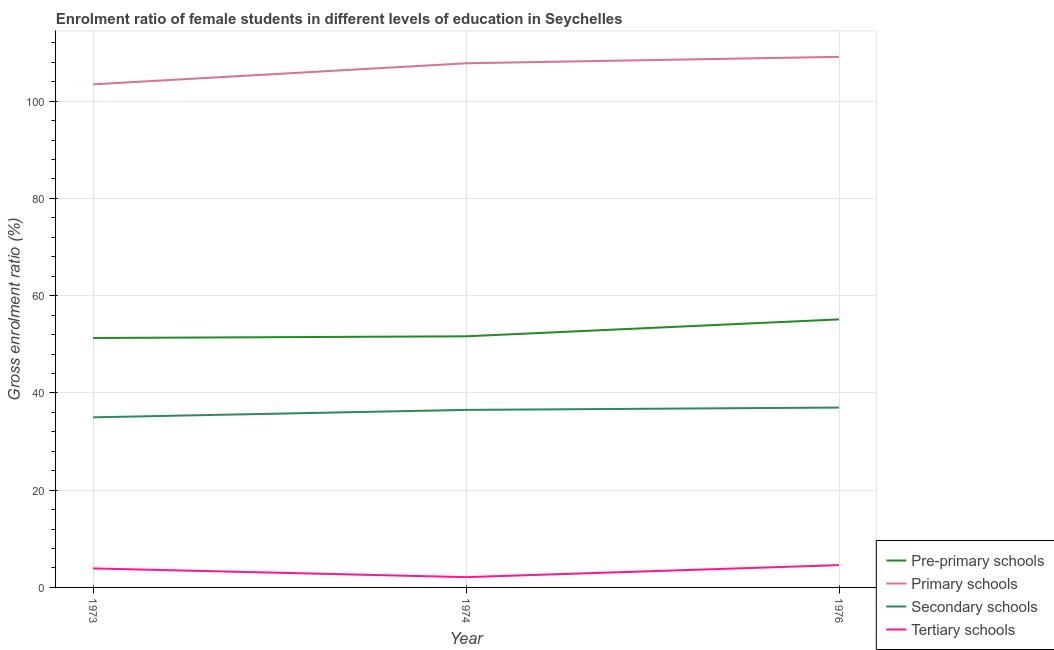How many different coloured lines are there?
Provide a succinct answer. 4. Is the number of lines equal to the number of legend labels?
Make the answer very short. Yes. What is the gross enrolment ratio(male) in secondary schools in 1973?
Your answer should be compact. 34.98. Across all years, what is the maximum gross enrolment ratio(male) in pre-primary schools?
Offer a terse response. 55.12. Across all years, what is the minimum gross enrolment ratio(male) in pre-primary schools?
Your answer should be very brief. 51.3. In which year was the gross enrolment ratio(male) in secondary schools maximum?
Offer a very short reply. 1976. What is the total gross enrolment ratio(male) in tertiary schools in the graph?
Your answer should be very brief. 10.61. What is the difference between the gross enrolment ratio(male) in primary schools in 1973 and that in 1976?
Ensure brevity in your answer.  -5.65. What is the difference between the gross enrolment ratio(male) in tertiary schools in 1974 and the gross enrolment ratio(male) in pre-primary schools in 1976?
Your answer should be compact. -53.01. What is the average gross enrolment ratio(male) in tertiary schools per year?
Your answer should be compact. 3.54. In the year 1974, what is the difference between the gross enrolment ratio(male) in primary schools and gross enrolment ratio(male) in secondary schools?
Your response must be concise. 71.28. In how many years, is the gross enrolment ratio(male) in primary schools greater than 24 %?
Give a very brief answer. 3. What is the ratio of the gross enrolment ratio(male) in primary schools in 1973 to that in 1976?
Provide a succinct answer. 0.95. What is the difference between the highest and the second highest gross enrolment ratio(male) in tertiary schools?
Offer a terse response. 0.67. What is the difference between the highest and the lowest gross enrolment ratio(male) in primary schools?
Provide a short and direct response. 5.65. In how many years, is the gross enrolment ratio(male) in tertiary schools greater than the average gross enrolment ratio(male) in tertiary schools taken over all years?
Offer a terse response. 2. Is the sum of the gross enrolment ratio(male) in primary schools in 1974 and 1976 greater than the maximum gross enrolment ratio(male) in tertiary schools across all years?
Your response must be concise. Yes. Is it the case that in every year, the sum of the gross enrolment ratio(male) in secondary schools and gross enrolment ratio(male) in primary schools is greater than the sum of gross enrolment ratio(male) in tertiary schools and gross enrolment ratio(male) in pre-primary schools?
Provide a short and direct response. Yes. What is the difference between two consecutive major ticks on the Y-axis?
Provide a succinct answer. 20. Where does the legend appear in the graph?
Offer a very short reply. Bottom right. How many legend labels are there?
Give a very brief answer. 4. How are the legend labels stacked?
Ensure brevity in your answer.  Vertical. What is the title of the graph?
Make the answer very short. Enrolment ratio of female students in different levels of education in Seychelles. Does "Denmark" appear as one of the legend labels in the graph?
Offer a terse response. No. What is the label or title of the X-axis?
Your answer should be compact. Year. What is the Gross enrolment ratio (%) in Pre-primary schools in 1973?
Your answer should be compact. 51.3. What is the Gross enrolment ratio (%) of Primary schools in 1973?
Offer a very short reply. 103.46. What is the Gross enrolment ratio (%) in Secondary schools in 1973?
Your response must be concise. 34.98. What is the Gross enrolment ratio (%) in Tertiary schools in 1973?
Your answer should be compact. 3.91. What is the Gross enrolment ratio (%) in Pre-primary schools in 1974?
Make the answer very short. 51.64. What is the Gross enrolment ratio (%) of Primary schools in 1974?
Offer a very short reply. 107.79. What is the Gross enrolment ratio (%) of Secondary schools in 1974?
Your response must be concise. 36.51. What is the Gross enrolment ratio (%) of Tertiary schools in 1974?
Your answer should be very brief. 2.11. What is the Gross enrolment ratio (%) of Pre-primary schools in 1976?
Offer a terse response. 55.12. What is the Gross enrolment ratio (%) in Primary schools in 1976?
Make the answer very short. 109.12. What is the Gross enrolment ratio (%) in Secondary schools in 1976?
Keep it short and to the point. 36.99. What is the Gross enrolment ratio (%) of Tertiary schools in 1976?
Make the answer very short. 4.58. Across all years, what is the maximum Gross enrolment ratio (%) in Pre-primary schools?
Offer a very short reply. 55.12. Across all years, what is the maximum Gross enrolment ratio (%) of Primary schools?
Offer a terse response. 109.12. Across all years, what is the maximum Gross enrolment ratio (%) of Secondary schools?
Offer a terse response. 36.99. Across all years, what is the maximum Gross enrolment ratio (%) of Tertiary schools?
Offer a very short reply. 4.58. Across all years, what is the minimum Gross enrolment ratio (%) in Pre-primary schools?
Your answer should be compact. 51.3. Across all years, what is the minimum Gross enrolment ratio (%) of Primary schools?
Ensure brevity in your answer.  103.46. Across all years, what is the minimum Gross enrolment ratio (%) in Secondary schools?
Ensure brevity in your answer.  34.98. Across all years, what is the minimum Gross enrolment ratio (%) in Tertiary schools?
Make the answer very short. 2.11. What is the total Gross enrolment ratio (%) of Pre-primary schools in the graph?
Give a very brief answer. 158.06. What is the total Gross enrolment ratio (%) of Primary schools in the graph?
Offer a very short reply. 320.38. What is the total Gross enrolment ratio (%) in Secondary schools in the graph?
Ensure brevity in your answer.  108.49. What is the total Gross enrolment ratio (%) of Tertiary schools in the graph?
Provide a short and direct response. 10.61. What is the difference between the Gross enrolment ratio (%) in Pre-primary schools in 1973 and that in 1974?
Ensure brevity in your answer.  -0.34. What is the difference between the Gross enrolment ratio (%) in Primary schools in 1973 and that in 1974?
Your response must be concise. -4.33. What is the difference between the Gross enrolment ratio (%) of Secondary schools in 1973 and that in 1974?
Give a very brief answer. -1.53. What is the difference between the Gross enrolment ratio (%) of Tertiary schools in 1973 and that in 1974?
Keep it short and to the point. 1.8. What is the difference between the Gross enrolment ratio (%) of Pre-primary schools in 1973 and that in 1976?
Provide a short and direct response. -3.83. What is the difference between the Gross enrolment ratio (%) in Primary schools in 1973 and that in 1976?
Give a very brief answer. -5.65. What is the difference between the Gross enrolment ratio (%) in Secondary schools in 1973 and that in 1976?
Offer a very short reply. -2.01. What is the difference between the Gross enrolment ratio (%) of Tertiary schools in 1973 and that in 1976?
Your answer should be very brief. -0.67. What is the difference between the Gross enrolment ratio (%) of Pre-primary schools in 1974 and that in 1976?
Give a very brief answer. -3.48. What is the difference between the Gross enrolment ratio (%) of Primary schools in 1974 and that in 1976?
Provide a short and direct response. -1.33. What is the difference between the Gross enrolment ratio (%) of Secondary schools in 1974 and that in 1976?
Your answer should be very brief. -0.48. What is the difference between the Gross enrolment ratio (%) in Tertiary schools in 1974 and that in 1976?
Provide a succinct answer. -2.47. What is the difference between the Gross enrolment ratio (%) of Pre-primary schools in 1973 and the Gross enrolment ratio (%) of Primary schools in 1974?
Your answer should be very brief. -56.49. What is the difference between the Gross enrolment ratio (%) in Pre-primary schools in 1973 and the Gross enrolment ratio (%) in Secondary schools in 1974?
Your answer should be very brief. 14.79. What is the difference between the Gross enrolment ratio (%) of Pre-primary schools in 1973 and the Gross enrolment ratio (%) of Tertiary schools in 1974?
Provide a succinct answer. 49.18. What is the difference between the Gross enrolment ratio (%) of Primary schools in 1973 and the Gross enrolment ratio (%) of Secondary schools in 1974?
Your answer should be very brief. 66.95. What is the difference between the Gross enrolment ratio (%) of Primary schools in 1973 and the Gross enrolment ratio (%) of Tertiary schools in 1974?
Offer a very short reply. 101.35. What is the difference between the Gross enrolment ratio (%) of Secondary schools in 1973 and the Gross enrolment ratio (%) of Tertiary schools in 1974?
Provide a succinct answer. 32.87. What is the difference between the Gross enrolment ratio (%) in Pre-primary schools in 1973 and the Gross enrolment ratio (%) in Primary schools in 1976?
Offer a very short reply. -57.82. What is the difference between the Gross enrolment ratio (%) of Pre-primary schools in 1973 and the Gross enrolment ratio (%) of Secondary schools in 1976?
Ensure brevity in your answer.  14.31. What is the difference between the Gross enrolment ratio (%) in Pre-primary schools in 1973 and the Gross enrolment ratio (%) in Tertiary schools in 1976?
Provide a short and direct response. 46.71. What is the difference between the Gross enrolment ratio (%) in Primary schools in 1973 and the Gross enrolment ratio (%) in Secondary schools in 1976?
Ensure brevity in your answer.  66.47. What is the difference between the Gross enrolment ratio (%) in Primary schools in 1973 and the Gross enrolment ratio (%) in Tertiary schools in 1976?
Make the answer very short. 98.88. What is the difference between the Gross enrolment ratio (%) in Secondary schools in 1973 and the Gross enrolment ratio (%) in Tertiary schools in 1976?
Keep it short and to the point. 30.4. What is the difference between the Gross enrolment ratio (%) in Pre-primary schools in 1974 and the Gross enrolment ratio (%) in Primary schools in 1976?
Provide a succinct answer. -57.48. What is the difference between the Gross enrolment ratio (%) in Pre-primary schools in 1974 and the Gross enrolment ratio (%) in Secondary schools in 1976?
Your response must be concise. 14.65. What is the difference between the Gross enrolment ratio (%) of Pre-primary schools in 1974 and the Gross enrolment ratio (%) of Tertiary schools in 1976?
Make the answer very short. 47.06. What is the difference between the Gross enrolment ratio (%) in Primary schools in 1974 and the Gross enrolment ratio (%) in Secondary schools in 1976?
Offer a terse response. 70.8. What is the difference between the Gross enrolment ratio (%) of Primary schools in 1974 and the Gross enrolment ratio (%) of Tertiary schools in 1976?
Offer a terse response. 103.21. What is the difference between the Gross enrolment ratio (%) of Secondary schools in 1974 and the Gross enrolment ratio (%) of Tertiary schools in 1976?
Your answer should be compact. 31.93. What is the average Gross enrolment ratio (%) in Pre-primary schools per year?
Offer a terse response. 52.69. What is the average Gross enrolment ratio (%) of Primary schools per year?
Your answer should be very brief. 106.79. What is the average Gross enrolment ratio (%) of Secondary schools per year?
Offer a terse response. 36.16. What is the average Gross enrolment ratio (%) in Tertiary schools per year?
Give a very brief answer. 3.54. In the year 1973, what is the difference between the Gross enrolment ratio (%) in Pre-primary schools and Gross enrolment ratio (%) in Primary schools?
Your response must be concise. -52.17. In the year 1973, what is the difference between the Gross enrolment ratio (%) in Pre-primary schools and Gross enrolment ratio (%) in Secondary schools?
Your answer should be very brief. 16.31. In the year 1973, what is the difference between the Gross enrolment ratio (%) of Pre-primary schools and Gross enrolment ratio (%) of Tertiary schools?
Ensure brevity in your answer.  47.39. In the year 1973, what is the difference between the Gross enrolment ratio (%) of Primary schools and Gross enrolment ratio (%) of Secondary schools?
Your response must be concise. 68.48. In the year 1973, what is the difference between the Gross enrolment ratio (%) of Primary schools and Gross enrolment ratio (%) of Tertiary schools?
Provide a succinct answer. 99.55. In the year 1973, what is the difference between the Gross enrolment ratio (%) of Secondary schools and Gross enrolment ratio (%) of Tertiary schools?
Make the answer very short. 31.07. In the year 1974, what is the difference between the Gross enrolment ratio (%) in Pre-primary schools and Gross enrolment ratio (%) in Primary schools?
Give a very brief answer. -56.15. In the year 1974, what is the difference between the Gross enrolment ratio (%) of Pre-primary schools and Gross enrolment ratio (%) of Secondary schools?
Ensure brevity in your answer.  15.13. In the year 1974, what is the difference between the Gross enrolment ratio (%) of Pre-primary schools and Gross enrolment ratio (%) of Tertiary schools?
Provide a short and direct response. 49.53. In the year 1974, what is the difference between the Gross enrolment ratio (%) in Primary schools and Gross enrolment ratio (%) in Secondary schools?
Provide a succinct answer. 71.28. In the year 1974, what is the difference between the Gross enrolment ratio (%) of Primary schools and Gross enrolment ratio (%) of Tertiary schools?
Ensure brevity in your answer.  105.68. In the year 1974, what is the difference between the Gross enrolment ratio (%) of Secondary schools and Gross enrolment ratio (%) of Tertiary schools?
Provide a succinct answer. 34.4. In the year 1976, what is the difference between the Gross enrolment ratio (%) in Pre-primary schools and Gross enrolment ratio (%) in Primary schools?
Provide a succinct answer. -53.99. In the year 1976, what is the difference between the Gross enrolment ratio (%) in Pre-primary schools and Gross enrolment ratio (%) in Secondary schools?
Ensure brevity in your answer.  18.13. In the year 1976, what is the difference between the Gross enrolment ratio (%) in Pre-primary schools and Gross enrolment ratio (%) in Tertiary schools?
Give a very brief answer. 50.54. In the year 1976, what is the difference between the Gross enrolment ratio (%) in Primary schools and Gross enrolment ratio (%) in Secondary schools?
Offer a very short reply. 72.13. In the year 1976, what is the difference between the Gross enrolment ratio (%) of Primary schools and Gross enrolment ratio (%) of Tertiary schools?
Make the answer very short. 104.53. In the year 1976, what is the difference between the Gross enrolment ratio (%) in Secondary schools and Gross enrolment ratio (%) in Tertiary schools?
Keep it short and to the point. 32.41. What is the ratio of the Gross enrolment ratio (%) in Pre-primary schools in 1973 to that in 1974?
Your answer should be compact. 0.99. What is the ratio of the Gross enrolment ratio (%) of Primary schools in 1973 to that in 1974?
Your response must be concise. 0.96. What is the ratio of the Gross enrolment ratio (%) of Secondary schools in 1973 to that in 1974?
Ensure brevity in your answer.  0.96. What is the ratio of the Gross enrolment ratio (%) of Tertiary schools in 1973 to that in 1974?
Provide a succinct answer. 1.85. What is the ratio of the Gross enrolment ratio (%) of Pre-primary schools in 1973 to that in 1976?
Give a very brief answer. 0.93. What is the ratio of the Gross enrolment ratio (%) of Primary schools in 1973 to that in 1976?
Offer a terse response. 0.95. What is the ratio of the Gross enrolment ratio (%) of Secondary schools in 1973 to that in 1976?
Provide a short and direct response. 0.95. What is the ratio of the Gross enrolment ratio (%) in Tertiary schools in 1973 to that in 1976?
Your answer should be compact. 0.85. What is the ratio of the Gross enrolment ratio (%) in Pre-primary schools in 1974 to that in 1976?
Your response must be concise. 0.94. What is the ratio of the Gross enrolment ratio (%) of Primary schools in 1974 to that in 1976?
Your response must be concise. 0.99. What is the ratio of the Gross enrolment ratio (%) in Secondary schools in 1974 to that in 1976?
Your response must be concise. 0.99. What is the ratio of the Gross enrolment ratio (%) of Tertiary schools in 1974 to that in 1976?
Offer a terse response. 0.46. What is the difference between the highest and the second highest Gross enrolment ratio (%) of Pre-primary schools?
Your answer should be compact. 3.48. What is the difference between the highest and the second highest Gross enrolment ratio (%) in Primary schools?
Provide a short and direct response. 1.33. What is the difference between the highest and the second highest Gross enrolment ratio (%) in Secondary schools?
Offer a terse response. 0.48. What is the difference between the highest and the second highest Gross enrolment ratio (%) in Tertiary schools?
Offer a very short reply. 0.67. What is the difference between the highest and the lowest Gross enrolment ratio (%) in Pre-primary schools?
Your answer should be very brief. 3.83. What is the difference between the highest and the lowest Gross enrolment ratio (%) of Primary schools?
Give a very brief answer. 5.65. What is the difference between the highest and the lowest Gross enrolment ratio (%) of Secondary schools?
Offer a terse response. 2.01. What is the difference between the highest and the lowest Gross enrolment ratio (%) in Tertiary schools?
Your response must be concise. 2.47. 